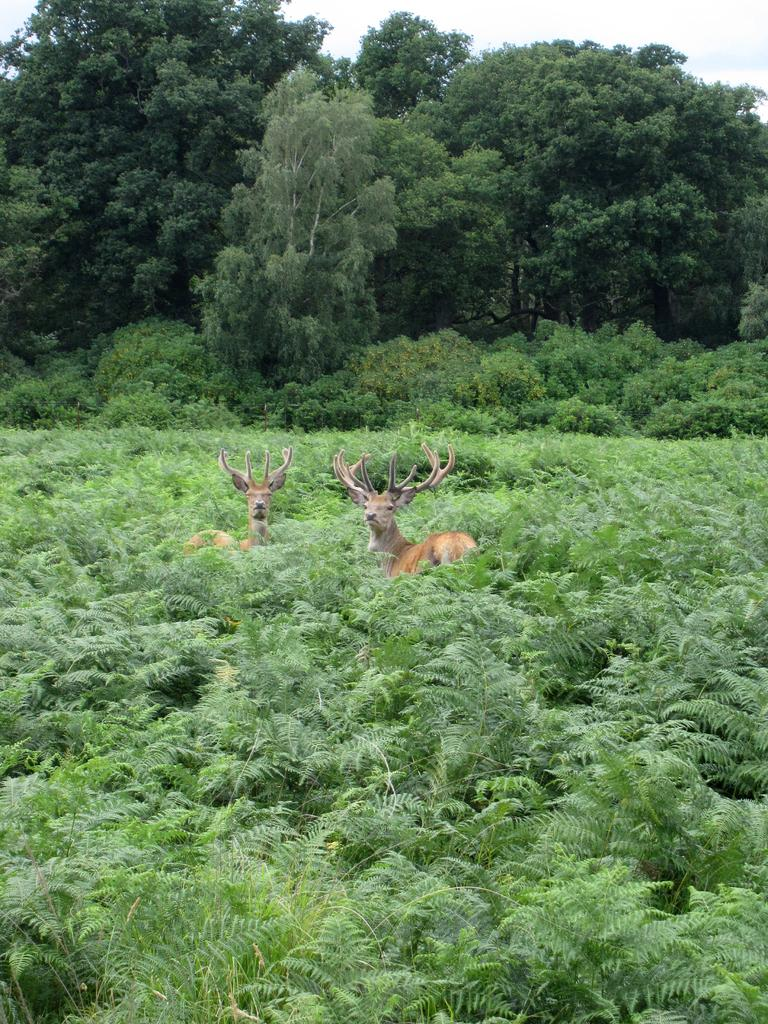What type of animals can be seen in the image? There are two brown animals in the image. What is the position of the animals in the image? The animals are standing on the ground. What type of vegetation is present in the image? There are plants in the image. What can be seen in the background of the image? There are trees and the sky visible in the background of the image. What type of linen is draped over the animals in the image? There is no linen present in the image; the animals are standing on the ground without any fabric draped over them. 